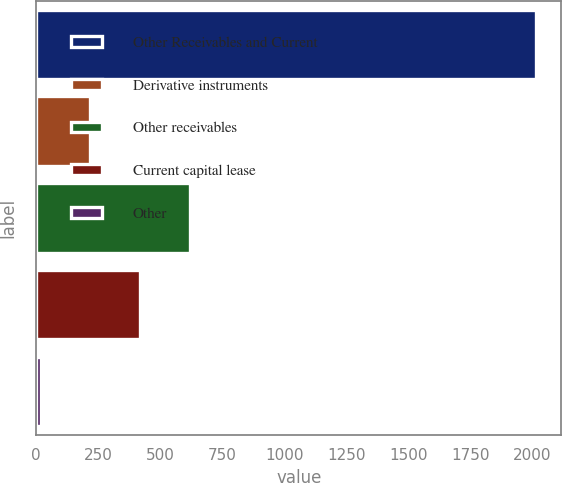<chart> <loc_0><loc_0><loc_500><loc_500><bar_chart><fcel>Other Receivables and Current<fcel>Derivative instruments<fcel>Other receivables<fcel>Current capital lease<fcel>Other<nl><fcel>2015<fcel>218.42<fcel>617.66<fcel>418.04<fcel>18.8<nl></chart> 